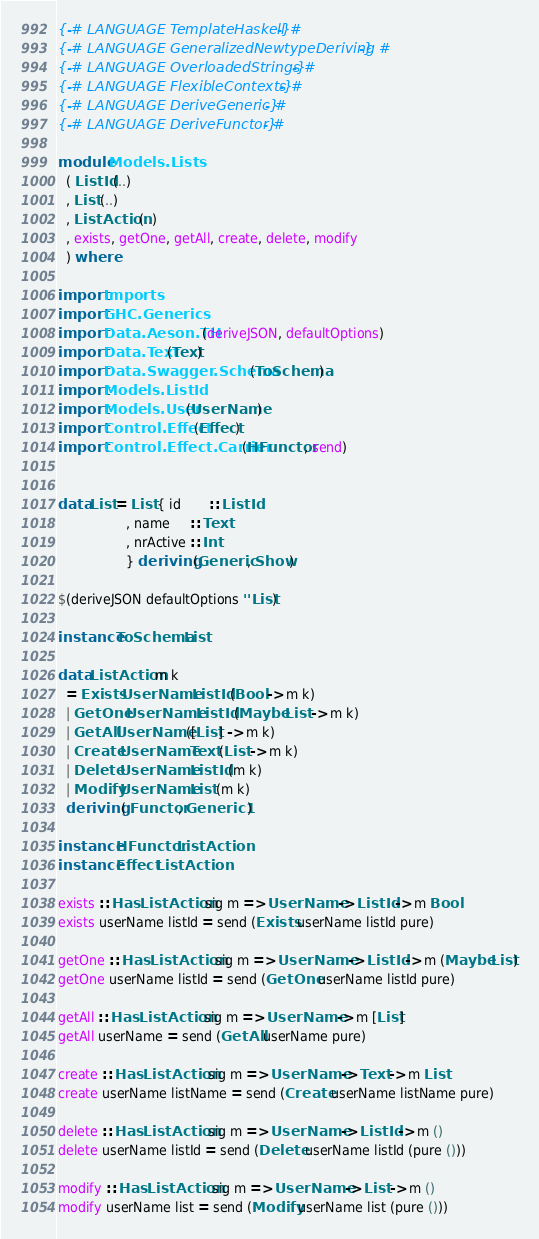Convert code to text. <code><loc_0><loc_0><loc_500><loc_500><_Haskell_>{-# LANGUAGE TemplateHaskell #-}
{-# LANGUAGE GeneralizedNewtypeDeriving #-}
{-# LANGUAGE OverloadedStrings #-}
{-# LANGUAGE FlexibleContexts #-}
{-# LANGUAGE DeriveGeneric #-}
{-# LANGUAGE DeriveFunctor #-}

module Models.Lists
  ( ListId (..)
  , List (..)
  , ListAction (..)
  , exists, getOne, getAll, create, delete, modify
  ) where

import Imports
import GHC.Generics
import Data.Aeson.TH (deriveJSON, defaultOptions)
import Data.Text (Text)
import Data.Swagger.Schema (ToSchema)
import Models.ListId
import Models.User (UserName)
import Control.Effect (Effect)
import Control.Effect.Carrier (HFunctor, send)


data List = List { id       :: ListId
                 , name     :: Text
                 , nrActive :: Int
                 } deriving (Generic, Show)

$(deriveJSON defaultOptions ''List)

instance ToSchema List

data ListAction m k
  = Exists UserName ListId (Bool -> m k)
  | GetOne UserName ListId (Maybe List -> m k)
  | GetAll UserName ([List] -> m k)
  | Create UserName Text (List -> m k)
  | Delete UserName ListId (m k)
  | Modify UserName List (m k)
  deriving ( Functor, Generic1 )

instance HFunctor ListAction
instance Effect ListAction

exists :: Has ListAction sig m => UserName -> ListId -> m Bool
exists userName listId = send (Exists userName listId pure) 

getOne :: Has ListAction sig m => UserName -> ListId -> m (Maybe List)
getOne userName listId = send (GetOne userName listId pure) 

getAll :: Has ListAction sig m => UserName -> m [List]
getAll userName = send (GetAll userName pure) 

create :: Has ListAction sig m => UserName -> Text -> m List
create userName listName = send (Create userName listName pure) 

delete :: Has ListAction sig m => UserName -> ListId -> m ()
delete userName listId = send (Delete userName listId (pure ())) 

modify :: Has ListAction sig m => UserName -> List -> m ()
modify userName list = send (Modify userName list (pure ())) 
</code> 